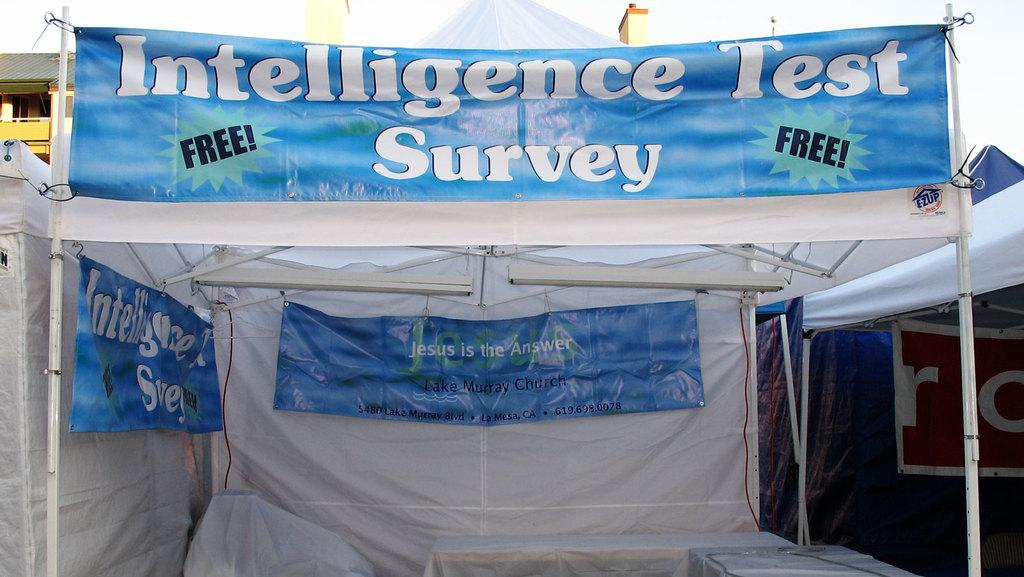What type of temporary shelters can be seen in the image? There are tents in the image. What is covering the table in the image? There is a tablecloth in the image. What can be seen providing illumination in the image? There are lights in the image. What are the long, thin, and upright structures in the image? There are poles in the image. What type of structures are visible in the background of the image? There are buildings in the image. What part of the natural environment is visible in the image? The sky is visible in the image. Based on the visible sky and the presence of lights, can we determine the time of day the image was taken? The image was likely taken during the day, as the sky appears bright and there are no visible stars or moon. Can you solve the riddle written on the dock in the image? There is no dock or riddle present in the image. How many times can you jump over the poles in the image? There is no need to jump over the poles in the image, as they are stationary structures. 